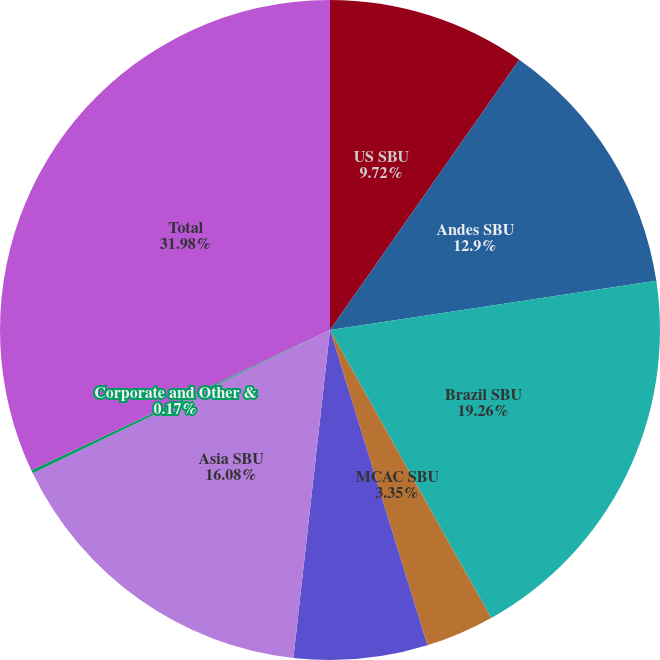Convert chart to OTSL. <chart><loc_0><loc_0><loc_500><loc_500><pie_chart><fcel>US SBU<fcel>Andes SBU<fcel>Brazil SBU<fcel>MCAC SBU<fcel>Europe SBU<fcel>Asia SBU<fcel>Corporate and Other &<fcel>Total<nl><fcel>9.72%<fcel>12.9%<fcel>19.26%<fcel>3.35%<fcel>6.54%<fcel>16.08%<fcel>0.17%<fcel>31.98%<nl></chart> 